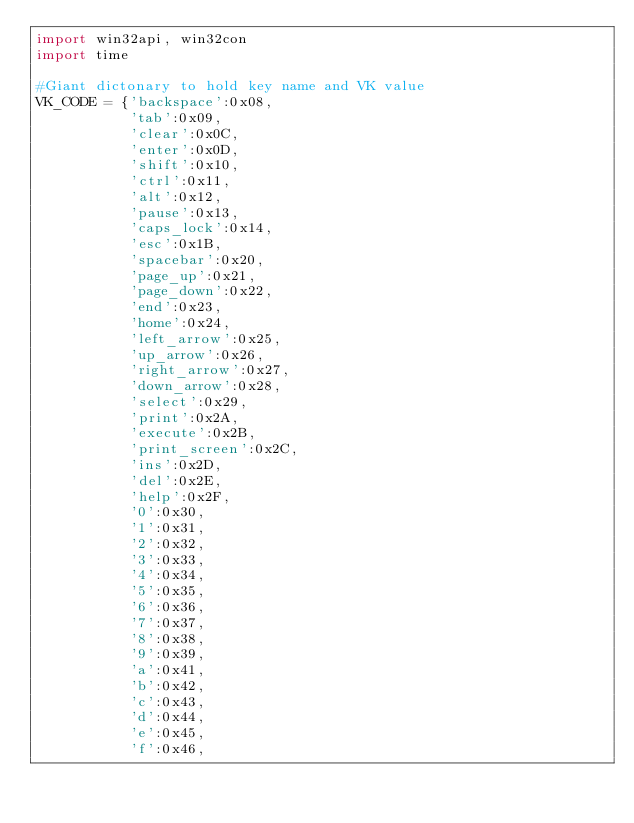<code> <loc_0><loc_0><loc_500><loc_500><_Python_>import win32api, win32con
import time

#Giant dictonary to hold key name and VK value
VK_CODE = {'backspace':0x08,
           'tab':0x09,
           'clear':0x0C,
           'enter':0x0D,
           'shift':0x10,
           'ctrl':0x11,
           'alt':0x12,
           'pause':0x13,
           'caps_lock':0x14,
           'esc':0x1B,
           'spacebar':0x20,
           'page_up':0x21,
           'page_down':0x22,
           'end':0x23,
           'home':0x24,
           'left_arrow':0x25,
           'up_arrow':0x26,
           'right_arrow':0x27,
           'down_arrow':0x28,
           'select':0x29,
           'print':0x2A,
           'execute':0x2B,
           'print_screen':0x2C,
           'ins':0x2D,
           'del':0x2E,
           'help':0x2F,
           '0':0x30,
           '1':0x31,
           '2':0x32,
           '3':0x33,
           '4':0x34,
           '5':0x35,
           '6':0x36,
           '7':0x37,
           '8':0x38,
           '9':0x39,
           'a':0x41,
           'b':0x42,
           'c':0x43,
           'd':0x44,
           'e':0x45,
           'f':0x46,</code> 